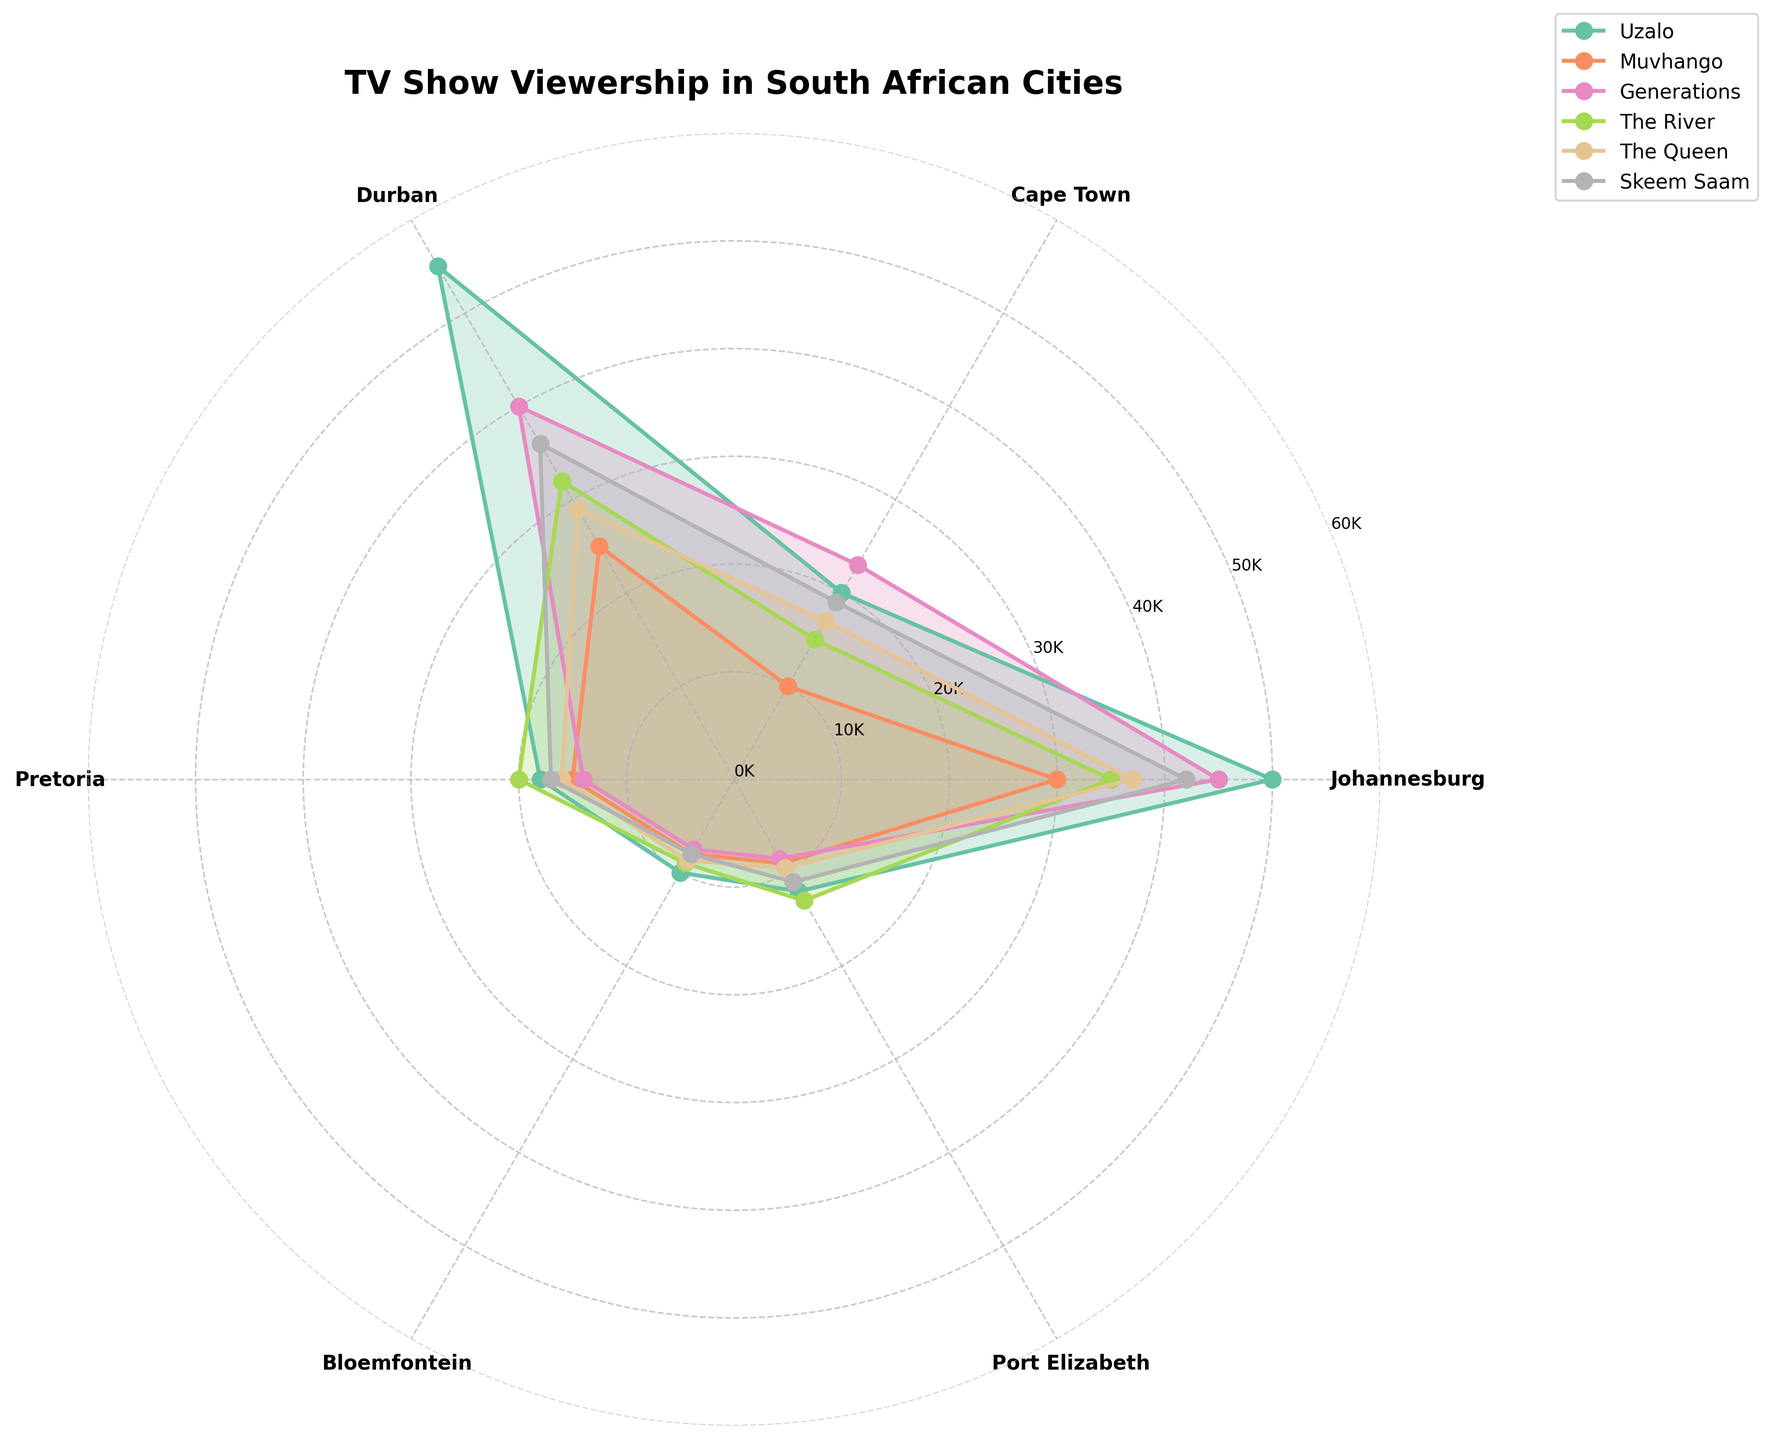what is the title of the plot? The title is prominently displayed at the top of the plot.
Answer: TV Show Viewership in South African Cities Which city has the highest viewership for "Uzalo"? The radial distance for each show towards the Johannesburg direction represents the viewership numbers. Johannesburg has the highest number for "Uzalo" at 50,000 viewers.
Answer: Johannesburg How many TV shows are represented in the plot? Each show is labeled and color-coded in the legend on the right side of the plot. There are six shows listed.
Answer: 6 Which TV show has the lowest viewership in Port Elizabeth? By looking at the radial distance corresponding to Port Elizabeth for each show's curve, "Muvhango" has the lowest viewership at 9,000 viewers.
Answer: Muvhango What is the combined viewership of "Skeem Saam" in Durban and Port Elizabeth? The radial distances for "Skeem Saam" in Durban and Port Elizabeth are 36,000 and 11,000 respectively. By adding these numbers, the total viewership is 47,000.
Answer: 47,000 Which TV show has a higher average viewership across the cities, "The River" or "Generations"? To find the average, sum the viewership numbers for each city for "The River" and "Generations" and then divide by the number of cities (6). "Generations" has 45000+23000+40000+14000+7500+8500=138000, average 138000/6=23000. "The River" has 35000+15000+32000+20000+9000+13000=124000, average 124000/6=20667.
Answer: Generations Which city has the most balanced viewership among all TV shows? A city with balanced viewership will have the least variability in the radial distances. Pretoria's viewership numbers for all shows are close to each other compared to other cities.
Answer: Pretoria Which city stands out as having the highest viewership for all shows combined? Sum the values for each city. Durban (55000+25000+40000+32000+29000+36000) has the highest combined viewership with 217,000.
Answer: Durban Is "Muvhango" in Pretoria more popular than "The Queen" in Bloemfontein? The radial distances for "Muvhango" in Pretoria and "The Queen" in Bloemfontein are 15,000 and 8,700 respectively. Since 15,000 is greater than 8,700, "Muvhango" in Pretoria is more popular.
Answer: Yes Which TV show's line has the smallest change in viewership across all cities and what does it indicate? Look for the show whose line plot has the least variation in radial distances. "Uzalo" appears relatively consistent across cities, indicating it has steady viewership irrespective of the city.
Answer: Uzalo 